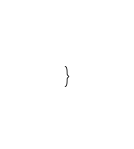Convert code to text. <code><loc_0><loc_0><loc_500><loc_500><_TypeScript_>}
</code> 